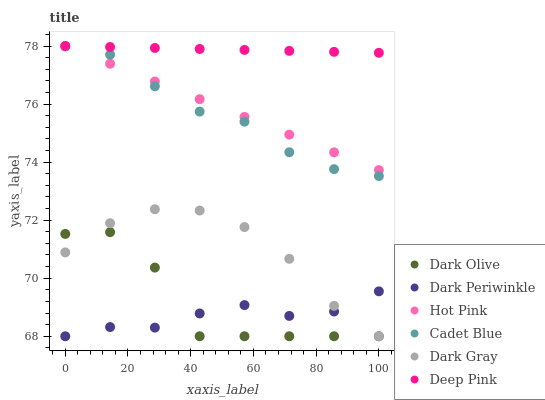Does Dark Periwinkle have the minimum area under the curve?
Answer yes or no. Yes. Does Deep Pink have the maximum area under the curve?
Answer yes or no. Yes. Does Dark Olive have the minimum area under the curve?
Answer yes or no. No. Does Dark Olive have the maximum area under the curve?
Answer yes or no. No. Is Hot Pink the smoothest?
Answer yes or no. Yes. Is Dark Olive the roughest?
Answer yes or no. Yes. Is Dark Gray the smoothest?
Answer yes or no. No. Is Dark Gray the roughest?
Answer yes or no. No. Does Dark Olive have the lowest value?
Answer yes or no. Yes. Does Deep Pink have the lowest value?
Answer yes or no. No. Does Hot Pink have the highest value?
Answer yes or no. Yes. Does Dark Olive have the highest value?
Answer yes or no. No. Is Dark Gray less than Deep Pink?
Answer yes or no. Yes. Is Deep Pink greater than Dark Olive?
Answer yes or no. Yes. Does Cadet Blue intersect Hot Pink?
Answer yes or no. Yes. Is Cadet Blue less than Hot Pink?
Answer yes or no. No. Is Cadet Blue greater than Hot Pink?
Answer yes or no. No. Does Dark Gray intersect Deep Pink?
Answer yes or no. No. 